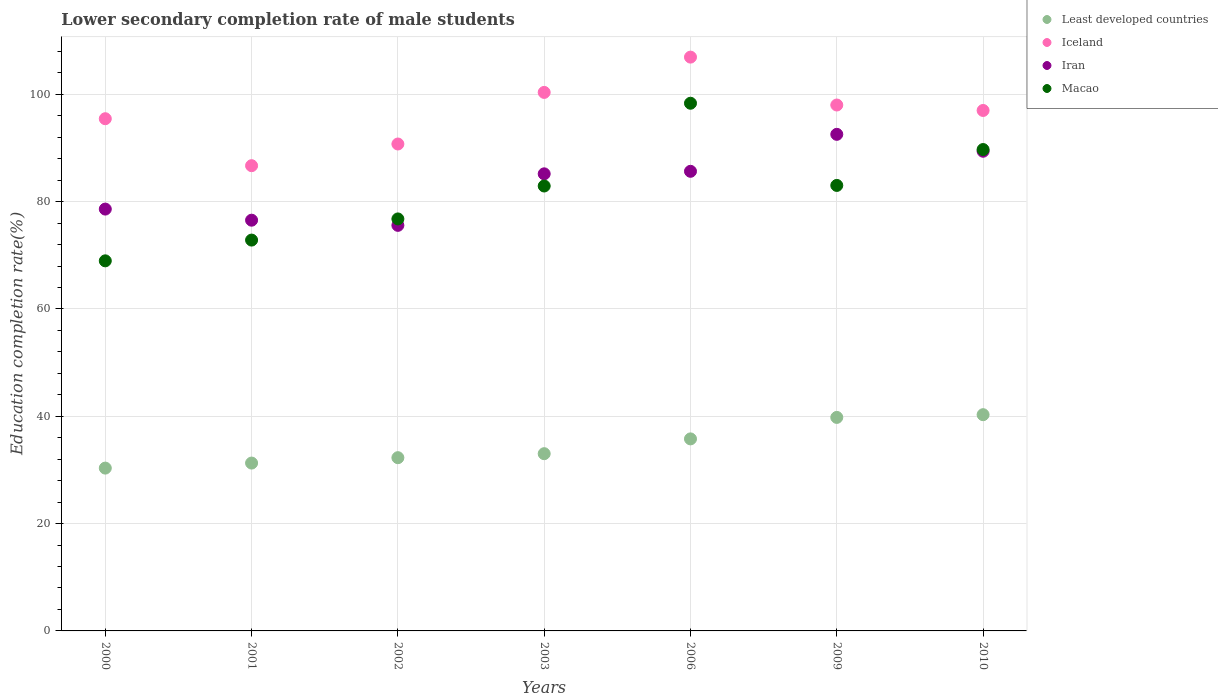How many different coloured dotlines are there?
Provide a succinct answer. 4. What is the lower secondary completion rate of male students in Iran in 2002?
Give a very brief answer. 75.59. Across all years, what is the maximum lower secondary completion rate of male students in Iran?
Keep it short and to the point. 92.55. Across all years, what is the minimum lower secondary completion rate of male students in Iceland?
Offer a terse response. 86.71. In which year was the lower secondary completion rate of male students in Macao maximum?
Your answer should be compact. 2006. In which year was the lower secondary completion rate of male students in Iceland minimum?
Make the answer very short. 2001. What is the total lower secondary completion rate of male students in Iran in the graph?
Your response must be concise. 583.57. What is the difference between the lower secondary completion rate of male students in Macao in 2001 and that in 2009?
Make the answer very short. -10.19. What is the difference between the lower secondary completion rate of male students in Iran in 2006 and the lower secondary completion rate of male students in Least developed countries in 2002?
Provide a short and direct response. 53.37. What is the average lower secondary completion rate of male students in Macao per year?
Your response must be concise. 81.8. In the year 2006, what is the difference between the lower secondary completion rate of male students in Iran and lower secondary completion rate of male students in Least developed countries?
Your answer should be very brief. 49.87. What is the ratio of the lower secondary completion rate of male students in Macao in 2001 to that in 2002?
Your answer should be compact. 0.95. Is the lower secondary completion rate of male students in Least developed countries in 2001 less than that in 2010?
Provide a short and direct response. Yes. Is the difference between the lower secondary completion rate of male students in Iran in 2000 and 2010 greater than the difference between the lower secondary completion rate of male students in Least developed countries in 2000 and 2010?
Offer a terse response. No. What is the difference between the highest and the second highest lower secondary completion rate of male students in Iran?
Make the answer very short. 3.15. What is the difference between the highest and the lowest lower secondary completion rate of male students in Iran?
Give a very brief answer. 16.96. Is the sum of the lower secondary completion rate of male students in Least developed countries in 2001 and 2009 greater than the maximum lower secondary completion rate of male students in Iran across all years?
Your answer should be compact. No. Does the lower secondary completion rate of male students in Least developed countries monotonically increase over the years?
Offer a very short reply. Yes. Is the lower secondary completion rate of male students in Iceland strictly less than the lower secondary completion rate of male students in Iran over the years?
Ensure brevity in your answer.  No. Does the graph contain any zero values?
Ensure brevity in your answer.  No. Does the graph contain grids?
Your answer should be compact. Yes. What is the title of the graph?
Give a very brief answer. Lower secondary completion rate of male students. Does "Fragile and conflict affected situations" appear as one of the legend labels in the graph?
Ensure brevity in your answer.  No. What is the label or title of the Y-axis?
Keep it short and to the point. Education completion rate(%). What is the Education completion rate(%) of Least developed countries in 2000?
Offer a terse response. 30.35. What is the Education completion rate(%) in Iceland in 2000?
Ensure brevity in your answer.  95.46. What is the Education completion rate(%) in Iran in 2000?
Offer a terse response. 78.62. What is the Education completion rate(%) in Macao in 2000?
Your answer should be compact. 68.98. What is the Education completion rate(%) of Least developed countries in 2001?
Provide a succinct answer. 31.28. What is the Education completion rate(%) of Iceland in 2001?
Make the answer very short. 86.71. What is the Education completion rate(%) in Iran in 2001?
Offer a very short reply. 76.55. What is the Education completion rate(%) in Macao in 2001?
Provide a short and direct response. 72.84. What is the Education completion rate(%) of Least developed countries in 2002?
Give a very brief answer. 32.29. What is the Education completion rate(%) in Iceland in 2002?
Give a very brief answer. 90.75. What is the Education completion rate(%) of Iran in 2002?
Provide a succinct answer. 75.59. What is the Education completion rate(%) in Macao in 2002?
Ensure brevity in your answer.  76.79. What is the Education completion rate(%) of Least developed countries in 2003?
Make the answer very short. 33.03. What is the Education completion rate(%) in Iceland in 2003?
Your answer should be very brief. 100.37. What is the Education completion rate(%) of Iran in 2003?
Provide a succinct answer. 85.19. What is the Education completion rate(%) of Macao in 2003?
Your response must be concise. 82.92. What is the Education completion rate(%) in Least developed countries in 2006?
Give a very brief answer. 35.79. What is the Education completion rate(%) in Iceland in 2006?
Your response must be concise. 106.94. What is the Education completion rate(%) of Iran in 2006?
Provide a short and direct response. 85.66. What is the Education completion rate(%) of Macao in 2006?
Give a very brief answer. 98.35. What is the Education completion rate(%) in Least developed countries in 2009?
Ensure brevity in your answer.  39.79. What is the Education completion rate(%) in Iceland in 2009?
Offer a very short reply. 98.02. What is the Education completion rate(%) in Iran in 2009?
Offer a terse response. 92.55. What is the Education completion rate(%) of Macao in 2009?
Provide a short and direct response. 83.03. What is the Education completion rate(%) of Least developed countries in 2010?
Keep it short and to the point. 40.3. What is the Education completion rate(%) in Iceland in 2010?
Your answer should be very brief. 97. What is the Education completion rate(%) of Iran in 2010?
Your answer should be very brief. 89.4. What is the Education completion rate(%) of Macao in 2010?
Your answer should be very brief. 89.72. Across all years, what is the maximum Education completion rate(%) of Least developed countries?
Give a very brief answer. 40.3. Across all years, what is the maximum Education completion rate(%) of Iceland?
Make the answer very short. 106.94. Across all years, what is the maximum Education completion rate(%) of Iran?
Keep it short and to the point. 92.55. Across all years, what is the maximum Education completion rate(%) in Macao?
Your response must be concise. 98.35. Across all years, what is the minimum Education completion rate(%) of Least developed countries?
Provide a short and direct response. 30.35. Across all years, what is the minimum Education completion rate(%) of Iceland?
Provide a succinct answer. 86.71. Across all years, what is the minimum Education completion rate(%) in Iran?
Your answer should be compact. 75.59. Across all years, what is the minimum Education completion rate(%) in Macao?
Make the answer very short. 68.98. What is the total Education completion rate(%) in Least developed countries in the graph?
Give a very brief answer. 242.84. What is the total Education completion rate(%) in Iceland in the graph?
Provide a short and direct response. 675.25. What is the total Education completion rate(%) of Iran in the graph?
Make the answer very short. 583.57. What is the total Education completion rate(%) in Macao in the graph?
Provide a succinct answer. 572.63. What is the difference between the Education completion rate(%) in Least developed countries in 2000 and that in 2001?
Your response must be concise. -0.94. What is the difference between the Education completion rate(%) in Iceland in 2000 and that in 2001?
Keep it short and to the point. 8.75. What is the difference between the Education completion rate(%) in Iran in 2000 and that in 2001?
Your answer should be compact. 2.07. What is the difference between the Education completion rate(%) in Macao in 2000 and that in 2001?
Give a very brief answer. -3.87. What is the difference between the Education completion rate(%) in Least developed countries in 2000 and that in 2002?
Provide a short and direct response. -1.94. What is the difference between the Education completion rate(%) of Iceland in 2000 and that in 2002?
Give a very brief answer. 4.71. What is the difference between the Education completion rate(%) in Iran in 2000 and that in 2002?
Your response must be concise. 3.03. What is the difference between the Education completion rate(%) of Macao in 2000 and that in 2002?
Your response must be concise. -7.81. What is the difference between the Education completion rate(%) of Least developed countries in 2000 and that in 2003?
Provide a succinct answer. -2.69. What is the difference between the Education completion rate(%) of Iceland in 2000 and that in 2003?
Give a very brief answer. -4.9. What is the difference between the Education completion rate(%) of Iran in 2000 and that in 2003?
Your answer should be compact. -6.57. What is the difference between the Education completion rate(%) of Macao in 2000 and that in 2003?
Make the answer very short. -13.95. What is the difference between the Education completion rate(%) of Least developed countries in 2000 and that in 2006?
Offer a terse response. -5.44. What is the difference between the Education completion rate(%) in Iceland in 2000 and that in 2006?
Make the answer very short. -11.48. What is the difference between the Education completion rate(%) of Iran in 2000 and that in 2006?
Ensure brevity in your answer.  -7.04. What is the difference between the Education completion rate(%) of Macao in 2000 and that in 2006?
Offer a very short reply. -29.37. What is the difference between the Education completion rate(%) in Least developed countries in 2000 and that in 2009?
Provide a short and direct response. -9.45. What is the difference between the Education completion rate(%) in Iceland in 2000 and that in 2009?
Give a very brief answer. -2.55. What is the difference between the Education completion rate(%) in Iran in 2000 and that in 2009?
Your answer should be compact. -13.93. What is the difference between the Education completion rate(%) in Macao in 2000 and that in 2009?
Offer a very short reply. -14.05. What is the difference between the Education completion rate(%) of Least developed countries in 2000 and that in 2010?
Ensure brevity in your answer.  -9.96. What is the difference between the Education completion rate(%) in Iceland in 2000 and that in 2010?
Your answer should be compact. -1.54. What is the difference between the Education completion rate(%) of Iran in 2000 and that in 2010?
Provide a short and direct response. -10.78. What is the difference between the Education completion rate(%) of Macao in 2000 and that in 2010?
Your response must be concise. -20.74. What is the difference between the Education completion rate(%) of Least developed countries in 2001 and that in 2002?
Offer a terse response. -1. What is the difference between the Education completion rate(%) of Iceland in 2001 and that in 2002?
Your response must be concise. -4.04. What is the difference between the Education completion rate(%) of Iran in 2001 and that in 2002?
Your answer should be compact. 0.96. What is the difference between the Education completion rate(%) in Macao in 2001 and that in 2002?
Provide a succinct answer. -3.94. What is the difference between the Education completion rate(%) of Least developed countries in 2001 and that in 2003?
Provide a succinct answer. -1.75. What is the difference between the Education completion rate(%) in Iceland in 2001 and that in 2003?
Provide a short and direct response. -13.66. What is the difference between the Education completion rate(%) in Iran in 2001 and that in 2003?
Offer a terse response. -8.64. What is the difference between the Education completion rate(%) in Macao in 2001 and that in 2003?
Offer a terse response. -10.08. What is the difference between the Education completion rate(%) in Least developed countries in 2001 and that in 2006?
Your response must be concise. -4.51. What is the difference between the Education completion rate(%) in Iceland in 2001 and that in 2006?
Provide a succinct answer. -20.23. What is the difference between the Education completion rate(%) of Iran in 2001 and that in 2006?
Your answer should be compact. -9.11. What is the difference between the Education completion rate(%) in Macao in 2001 and that in 2006?
Make the answer very short. -25.5. What is the difference between the Education completion rate(%) in Least developed countries in 2001 and that in 2009?
Offer a terse response. -8.51. What is the difference between the Education completion rate(%) of Iceland in 2001 and that in 2009?
Keep it short and to the point. -11.31. What is the difference between the Education completion rate(%) in Iran in 2001 and that in 2009?
Make the answer very short. -16. What is the difference between the Education completion rate(%) in Macao in 2001 and that in 2009?
Ensure brevity in your answer.  -10.19. What is the difference between the Education completion rate(%) in Least developed countries in 2001 and that in 2010?
Your response must be concise. -9.02. What is the difference between the Education completion rate(%) of Iceland in 2001 and that in 2010?
Your answer should be compact. -10.29. What is the difference between the Education completion rate(%) of Iran in 2001 and that in 2010?
Your answer should be very brief. -12.85. What is the difference between the Education completion rate(%) of Macao in 2001 and that in 2010?
Give a very brief answer. -16.88. What is the difference between the Education completion rate(%) of Least developed countries in 2002 and that in 2003?
Ensure brevity in your answer.  -0.74. What is the difference between the Education completion rate(%) in Iceland in 2002 and that in 2003?
Provide a succinct answer. -9.62. What is the difference between the Education completion rate(%) in Iran in 2002 and that in 2003?
Your answer should be very brief. -9.6. What is the difference between the Education completion rate(%) of Macao in 2002 and that in 2003?
Ensure brevity in your answer.  -6.14. What is the difference between the Education completion rate(%) in Least developed countries in 2002 and that in 2006?
Provide a short and direct response. -3.5. What is the difference between the Education completion rate(%) of Iceland in 2002 and that in 2006?
Ensure brevity in your answer.  -16.19. What is the difference between the Education completion rate(%) of Iran in 2002 and that in 2006?
Provide a succinct answer. -10.07. What is the difference between the Education completion rate(%) of Macao in 2002 and that in 2006?
Your answer should be very brief. -21.56. What is the difference between the Education completion rate(%) in Least developed countries in 2002 and that in 2009?
Ensure brevity in your answer.  -7.51. What is the difference between the Education completion rate(%) in Iceland in 2002 and that in 2009?
Your response must be concise. -7.27. What is the difference between the Education completion rate(%) in Iran in 2002 and that in 2009?
Provide a short and direct response. -16.96. What is the difference between the Education completion rate(%) of Macao in 2002 and that in 2009?
Offer a terse response. -6.24. What is the difference between the Education completion rate(%) in Least developed countries in 2002 and that in 2010?
Provide a short and direct response. -8.01. What is the difference between the Education completion rate(%) in Iceland in 2002 and that in 2010?
Offer a very short reply. -6.25. What is the difference between the Education completion rate(%) in Iran in 2002 and that in 2010?
Offer a terse response. -13.81. What is the difference between the Education completion rate(%) in Macao in 2002 and that in 2010?
Your answer should be very brief. -12.93. What is the difference between the Education completion rate(%) of Least developed countries in 2003 and that in 2006?
Provide a short and direct response. -2.76. What is the difference between the Education completion rate(%) of Iceland in 2003 and that in 2006?
Keep it short and to the point. -6.58. What is the difference between the Education completion rate(%) in Iran in 2003 and that in 2006?
Your answer should be compact. -0.47. What is the difference between the Education completion rate(%) of Macao in 2003 and that in 2006?
Give a very brief answer. -15.42. What is the difference between the Education completion rate(%) in Least developed countries in 2003 and that in 2009?
Give a very brief answer. -6.76. What is the difference between the Education completion rate(%) in Iceland in 2003 and that in 2009?
Offer a very short reply. 2.35. What is the difference between the Education completion rate(%) in Iran in 2003 and that in 2009?
Your answer should be very brief. -7.36. What is the difference between the Education completion rate(%) of Macao in 2003 and that in 2009?
Provide a short and direct response. -0.11. What is the difference between the Education completion rate(%) of Least developed countries in 2003 and that in 2010?
Provide a short and direct response. -7.27. What is the difference between the Education completion rate(%) in Iceland in 2003 and that in 2010?
Provide a succinct answer. 3.37. What is the difference between the Education completion rate(%) in Iran in 2003 and that in 2010?
Provide a short and direct response. -4.21. What is the difference between the Education completion rate(%) in Macao in 2003 and that in 2010?
Your response must be concise. -6.8. What is the difference between the Education completion rate(%) of Least developed countries in 2006 and that in 2009?
Make the answer very short. -4. What is the difference between the Education completion rate(%) of Iceland in 2006 and that in 2009?
Give a very brief answer. 8.93. What is the difference between the Education completion rate(%) of Iran in 2006 and that in 2009?
Your response must be concise. -6.89. What is the difference between the Education completion rate(%) in Macao in 2006 and that in 2009?
Your response must be concise. 15.32. What is the difference between the Education completion rate(%) of Least developed countries in 2006 and that in 2010?
Your response must be concise. -4.51. What is the difference between the Education completion rate(%) in Iceland in 2006 and that in 2010?
Offer a terse response. 9.94. What is the difference between the Education completion rate(%) of Iran in 2006 and that in 2010?
Provide a short and direct response. -3.74. What is the difference between the Education completion rate(%) in Macao in 2006 and that in 2010?
Make the answer very short. 8.63. What is the difference between the Education completion rate(%) of Least developed countries in 2009 and that in 2010?
Provide a succinct answer. -0.51. What is the difference between the Education completion rate(%) of Iceland in 2009 and that in 2010?
Provide a short and direct response. 1.02. What is the difference between the Education completion rate(%) in Iran in 2009 and that in 2010?
Offer a very short reply. 3.15. What is the difference between the Education completion rate(%) of Macao in 2009 and that in 2010?
Offer a terse response. -6.69. What is the difference between the Education completion rate(%) of Least developed countries in 2000 and the Education completion rate(%) of Iceland in 2001?
Provide a succinct answer. -56.36. What is the difference between the Education completion rate(%) in Least developed countries in 2000 and the Education completion rate(%) in Iran in 2001?
Keep it short and to the point. -46.21. What is the difference between the Education completion rate(%) in Least developed countries in 2000 and the Education completion rate(%) in Macao in 2001?
Provide a short and direct response. -42.5. What is the difference between the Education completion rate(%) of Iceland in 2000 and the Education completion rate(%) of Iran in 2001?
Make the answer very short. 18.91. What is the difference between the Education completion rate(%) in Iceland in 2000 and the Education completion rate(%) in Macao in 2001?
Offer a very short reply. 22.62. What is the difference between the Education completion rate(%) in Iran in 2000 and the Education completion rate(%) in Macao in 2001?
Provide a succinct answer. 5.78. What is the difference between the Education completion rate(%) of Least developed countries in 2000 and the Education completion rate(%) of Iceland in 2002?
Your answer should be very brief. -60.41. What is the difference between the Education completion rate(%) of Least developed countries in 2000 and the Education completion rate(%) of Iran in 2002?
Provide a succinct answer. -45.24. What is the difference between the Education completion rate(%) in Least developed countries in 2000 and the Education completion rate(%) in Macao in 2002?
Your answer should be very brief. -46.44. What is the difference between the Education completion rate(%) of Iceland in 2000 and the Education completion rate(%) of Iran in 2002?
Your answer should be compact. 19.87. What is the difference between the Education completion rate(%) in Iceland in 2000 and the Education completion rate(%) in Macao in 2002?
Keep it short and to the point. 18.68. What is the difference between the Education completion rate(%) in Iran in 2000 and the Education completion rate(%) in Macao in 2002?
Give a very brief answer. 1.84. What is the difference between the Education completion rate(%) in Least developed countries in 2000 and the Education completion rate(%) in Iceland in 2003?
Provide a succinct answer. -70.02. What is the difference between the Education completion rate(%) of Least developed countries in 2000 and the Education completion rate(%) of Iran in 2003?
Keep it short and to the point. -54.85. What is the difference between the Education completion rate(%) in Least developed countries in 2000 and the Education completion rate(%) in Macao in 2003?
Provide a succinct answer. -52.58. What is the difference between the Education completion rate(%) in Iceland in 2000 and the Education completion rate(%) in Iran in 2003?
Your answer should be very brief. 10.27. What is the difference between the Education completion rate(%) in Iceland in 2000 and the Education completion rate(%) in Macao in 2003?
Provide a short and direct response. 12.54. What is the difference between the Education completion rate(%) in Iran in 2000 and the Education completion rate(%) in Macao in 2003?
Your response must be concise. -4.3. What is the difference between the Education completion rate(%) of Least developed countries in 2000 and the Education completion rate(%) of Iceland in 2006?
Offer a terse response. -76.6. What is the difference between the Education completion rate(%) of Least developed countries in 2000 and the Education completion rate(%) of Iran in 2006?
Your answer should be very brief. -55.32. What is the difference between the Education completion rate(%) in Least developed countries in 2000 and the Education completion rate(%) in Macao in 2006?
Offer a terse response. -68. What is the difference between the Education completion rate(%) of Iceland in 2000 and the Education completion rate(%) of Iran in 2006?
Provide a succinct answer. 9.8. What is the difference between the Education completion rate(%) of Iceland in 2000 and the Education completion rate(%) of Macao in 2006?
Your response must be concise. -2.88. What is the difference between the Education completion rate(%) in Iran in 2000 and the Education completion rate(%) in Macao in 2006?
Offer a terse response. -19.73. What is the difference between the Education completion rate(%) in Least developed countries in 2000 and the Education completion rate(%) in Iceland in 2009?
Keep it short and to the point. -67.67. What is the difference between the Education completion rate(%) of Least developed countries in 2000 and the Education completion rate(%) of Iran in 2009?
Keep it short and to the point. -62.21. What is the difference between the Education completion rate(%) of Least developed countries in 2000 and the Education completion rate(%) of Macao in 2009?
Provide a succinct answer. -52.68. What is the difference between the Education completion rate(%) of Iceland in 2000 and the Education completion rate(%) of Iran in 2009?
Your answer should be very brief. 2.91. What is the difference between the Education completion rate(%) in Iceland in 2000 and the Education completion rate(%) in Macao in 2009?
Offer a terse response. 12.43. What is the difference between the Education completion rate(%) in Iran in 2000 and the Education completion rate(%) in Macao in 2009?
Provide a short and direct response. -4.41. What is the difference between the Education completion rate(%) in Least developed countries in 2000 and the Education completion rate(%) in Iceland in 2010?
Offer a very short reply. -66.66. What is the difference between the Education completion rate(%) of Least developed countries in 2000 and the Education completion rate(%) of Iran in 2010?
Your answer should be compact. -59.05. What is the difference between the Education completion rate(%) in Least developed countries in 2000 and the Education completion rate(%) in Macao in 2010?
Give a very brief answer. -59.37. What is the difference between the Education completion rate(%) of Iceland in 2000 and the Education completion rate(%) of Iran in 2010?
Offer a very short reply. 6.06. What is the difference between the Education completion rate(%) in Iceland in 2000 and the Education completion rate(%) in Macao in 2010?
Your response must be concise. 5.74. What is the difference between the Education completion rate(%) of Iran in 2000 and the Education completion rate(%) of Macao in 2010?
Ensure brevity in your answer.  -11.1. What is the difference between the Education completion rate(%) in Least developed countries in 2001 and the Education completion rate(%) in Iceland in 2002?
Make the answer very short. -59.47. What is the difference between the Education completion rate(%) in Least developed countries in 2001 and the Education completion rate(%) in Iran in 2002?
Offer a terse response. -44.3. What is the difference between the Education completion rate(%) in Least developed countries in 2001 and the Education completion rate(%) in Macao in 2002?
Your response must be concise. -45.5. What is the difference between the Education completion rate(%) in Iceland in 2001 and the Education completion rate(%) in Iran in 2002?
Provide a succinct answer. 11.12. What is the difference between the Education completion rate(%) of Iceland in 2001 and the Education completion rate(%) of Macao in 2002?
Make the answer very short. 9.92. What is the difference between the Education completion rate(%) in Iran in 2001 and the Education completion rate(%) in Macao in 2002?
Make the answer very short. -0.23. What is the difference between the Education completion rate(%) of Least developed countries in 2001 and the Education completion rate(%) of Iceland in 2003?
Provide a short and direct response. -69.08. What is the difference between the Education completion rate(%) in Least developed countries in 2001 and the Education completion rate(%) in Iran in 2003?
Your response must be concise. -53.91. What is the difference between the Education completion rate(%) of Least developed countries in 2001 and the Education completion rate(%) of Macao in 2003?
Make the answer very short. -51.64. What is the difference between the Education completion rate(%) in Iceland in 2001 and the Education completion rate(%) in Iran in 2003?
Your response must be concise. 1.52. What is the difference between the Education completion rate(%) in Iceland in 2001 and the Education completion rate(%) in Macao in 2003?
Give a very brief answer. 3.79. What is the difference between the Education completion rate(%) of Iran in 2001 and the Education completion rate(%) of Macao in 2003?
Make the answer very short. -6.37. What is the difference between the Education completion rate(%) of Least developed countries in 2001 and the Education completion rate(%) of Iceland in 2006?
Give a very brief answer. -75.66. What is the difference between the Education completion rate(%) of Least developed countries in 2001 and the Education completion rate(%) of Iran in 2006?
Provide a short and direct response. -54.38. What is the difference between the Education completion rate(%) in Least developed countries in 2001 and the Education completion rate(%) in Macao in 2006?
Make the answer very short. -67.06. What is the difference between the Education completion rate(%) of Iceland in 2001 and the Education completion rate(%) of Iran in 2006?
Give a very brief answer. 1.05. What is the difference between the Education completion rate(%) in Iceland in 2001 and the Education completion rate(%) in Macao in 2006?
Your answer should be very brief. -11.64. What is the difference between the Education completion rate(%) of Iran in 2001 and the Education completion rate(%) of Macao in 2006?
Ensure brevity in your answer.  -21.8. What is the difference between the Education completion rate(%) in Least developed countries in 2001 and the Education completion rate(%) in Iceland in 2009?
Your response must be concise. -66.73. What is the difference between the Education completion rate(%) in Least developed countries in 2001 and the Education completion rate(%) in Iran in 2009?
Your answer should be compact. -61.27. What is the difference between the Education completion rate(%) of Least developed countries in 2001 and the Education completion rate(%) of Macao in 2009?
Give a very brief answer. -51.75. What is the difference between the Education completion rate(%) in Iceland in 2001 and the Education completion rate(%) in Iran in 2009?
Your answer should be compact. -5.84. What is the difference between the Education completion rate(%) in Iceland in 2001 and the Education completion rate(%) in Macao in 2009?
Make the answer very short. 3.68. What is the difference between the Education completion rate(%) of Iran in 2001 and the Education completion rate(%) of Macao in 2009?
Give a very brief answer. -6.48. What is the difference between the Education completion rate(%) in Least developed countries in 2001 and the Education completion rate(%) in Iceland in 2010?
Your answer should be very brief. -65.72. What is the difference between the Education completion rate(%) in Least developed countries in 2001 and the Education completion rate(%) in Iran in 2010?
Your answer should be compact. -58.12. What is the difference between the Education completion rate(%) of Least developed countries in 2001 and the Education completion rate(%) of Macao in 2010?
Ensure brevity in your answer.  -58.44. What is the difference between the Education completion rate(%) of Iceland in 2001 and the Education completion rate(%) of Iran in 2010?
Offer a terse response. -2.69. What is the difference between the Education completion rate(%) of Iceland in 2001 and the Education completion rate(%) of Macao in 2010?
Give a very brief answer. -3.01. What is the difference between the Education completion rate(%) in Iran in 2001 and the Education completion rate(%) in Macao in 2010?
Provide a succinct answer. -13.17. What is the difference between the Education completion rate(%) of Least developed countries in 2002 and the Education completion rate(%) of Iceland in 2003?
Keep it short and to the point. -68.08. What is the difference between the Education completion rate(%) of Least developed countries in 2002 and the Education completion rate(%) of Iran in 2003?
Offer a terse response. -52.9. What is the difference between the Education completion rate(%) in Least developed countries in 2002 and the Education completion rate(%) in Macao in 2003?
Provide a succinct answer. -50.63. What is the difference between the Education completion rate(%) in Iceland in 2002 and the Education completion rate(%) in Iran in 2003?
Your answer should be compact. 5.56. What is the difference between the Education completion rate(%) of Iceland in 2002 and the Education completion rate(%) of Macao in 2003?
Offer a terse response. 7.83. What is the difference between the Education completion rate(%) of Iran in 2002 and the Education completion rate(%) of Macao in 2003?
Your answer should be compact. -7.33. What is the difference between the Education completion rate(%) in Least developed countries in 2002 and the Education completion rate(%) in Iceland in 2006?
Provide a succinct answer. -74.66. What is the difference between the Education completion rate(%) in Least developed countries in 2002 and the Education completion rate(%) in Iran in 2006?
Offer a terse response. -53.37. What is the difference between the Education completion rate(%) in Least developed countries in 2002 and the Education completion rate(%) in Macao in 2006?
Your response must be concise. -66.06. What is the difference between the Education completion rate(%) in Iceland in 2002 and the Education completion rate(%) in Iran in 2006?
Your answer should be compact. 5.09. What is the difference between the Education completion rate(%) in Iceland in 2002 and the Education completion rate(%) in Macao in 2006?
Give a very brief answer. -7.6. What is the difference between the Education completion rate(%) of Iran in 2002 and the Education completion rate(%) of Macao in 2006?
Give a very brief answer. -22.76. What is the difference between the Education completion rate(%) of Least developed countries in 2002 and the Education completion rate(%) of Iceland in 2009?
Give a very brief answer. -65.73. What is the difference between the Education completion rate(%) of Least developed countries in 2002 and the Education completion rate(%) of Iran in 2009?
Make the answer very short. -60.26. What is the difference between the Education completion rate(%) in Least developed countries in 2002 and the Education completion rate(%) in Macao in 2009?
Provide a succinct answer. -50.74. What is the difference between the Education completion rate(%) in Iceland in 2002 and the Education completion rate(%) in Iran in 2009?
Make the answer very short. -1.8. What is the difference between the Education completion rate(%) of Iceland in 2002 and the Education completion rate(%) of Macao in 2009?
Offer a very short reply. 7.72. What is the difference between the Education completion rate(%) of Iran in 2002 and the Education completion rate(%) of Macao in 2009?
Your response must be concise. -7.44. What is the difference between the Education completion rate(%) in Least developed countries in 2002 and the Education completion rate(%) in Iceland in 2010?
Provide a succinct answer. -64.71. What is the difference between the Education completion rate(%) in Least developed countries in 2002 and the Education completion rate(%) in Iran in 2010?
Offer a terse response. -57.11. What is the difference between the Education completion rate(%) in Least developed countries in 2002 and the Education completion rate(%) in Macao in 2010?
Offer a very short reply. -57.43. What is the difference between the Education completion rate(%) in Iceland in 2002 and the Education completion rate(%) in Iran in 2010?
Your response must be concise. 1.35. What is the difference between the Education completion rate(%) of Iceland in 2002 and the Education completion rate(%) of Macao in 2010?
Your answer should be compact. 1.03. What is the difference between the Education completion rate(%) of Iran in 2002 and the Education completion rate(%) of Macao in 2010?
Offer a terse response. -14.13. What is the difference between the Education completion rate(%) of Least developed countries in 2003 and the Education completion rate(%) of Iceland in 2006?
Your answer should be very brief. -73.91. What is the difference between the Education completion rate(%) of Least developed countries in 2003 and the Education completion rate(%) of Iran in 2006?
Your response must be concise. -52.63. What is the difference between the Education completion rate(%) in Least developed countries in 2003 and the Education completion rate(%) in Macao in 2006?
Your response must be concise. -65.31. What is the difference between the Education completion rate(%) in Iceland in 2003 and the Education completion rate(%) in Iran in 2006?
Your answer should be very brief. 14.7. What is the difference between the Education completion rate(%) in Iceland in 2003 and the Education completion rate(%) in Macao in 2006?
Your answer should be compact. 2.02. What is the difference between the Education completion rate(%) of Iran in 2003 and the Education completion rate(%) of Macao in 2006?
Offer a very short reply. -13.15. What is the difference between the Education completion rate(%) of Least developed countries in 2003 and the Education completion rate(%) of Iceland in 2009?
Offer a terse response. -64.98. What is the difference between the Education completion rate(%) in Least developed countries in 2003 and the Education completion rate(%) in Iran in 2009?
Your answer should be very brief. -59.52. What is the difference between the Education completion rate(%) in Least developed countries in 2003 and the Education completion rate(%) in Macao in 2009?
Make the answer very short. -50. What is the difference between the Education completion rate(%) in Iceland in 2003 and the Education completion rate(%) in Iran in 2009?
Keep it short and to the point. 7.81. What is the difference between the Education completion rate(%) in Iceland in 2003 and the Education completion rate(%) in Macao in 2009?
Provide a succinct answer. 17.34. What is the difference between the Education completion rate(%) of Iran in 2003 and the Education completion rate(%) of Macao in 2009?
Provide a short and direct response. 2.16. What is the difference between the Education completion rate(%) in Least developed countries in 2003 and the Education completion rate(%) in Iceland in 2010?
Provide a short and direct response. -63.97. What is the difference between the Education completion rate(%) in Least developed countries in 2003 and the Education completion rate(%) in Iran in 2010?
Keep it short and to the point. -56.37. What is the difference between the Education completion rate(%) in Least developed countries in 2003 and the Education completion rate(%) in Macao in 2010?
Your answer should be very brief. -56.69. What is the difference between the Education completion rate(%) of Iceland in 2003 and the Education completion rate(%) of Iran in 2010?
Give a very brief answer. 10.97. What is the difference between the Education completion rate(%) of Iceland in 2003 and the Education completion rate(%) of Macao in 2010?
Your answer should be very brief. 10.65. What is the difference between the Education completion rate(%) in Iran in 2003 and the Education completion rate(%) in Macao in 2010?
Provide a succinct answer. -4.53. What is the difference between the Education completion rate(%) of Least developed countries in 2006 and the Education completion rate(%) of Iceland in 2009?
Provide a succinct answer. -62.23. What is the difference between the Education completion rate(%) in Least developed countries in 2006 and the Education completion rate(%) in Iran in 2009?
Provide a succinct answer. -56.76. What is the difference between the Education completion rate(%) in Least developed countries in 2006 and the Education completion rate(%) in Macao in 2009?
Your answer should be very brief. -47.24. What is the difference between the Education completion rate(%) in Iceland in 2006 and the Education completion rate(%) in Iran in 2009?
Offer a very short reply. 14.39. What is the difference between the Education completion rate(%) of Iceland in 2006 and the Education completion rate(%) of Macao in 2009?
Offer a very short reply. 23.91. What is the difference between the Education completion rate(%) of Iran in 2006 and the Education completion rate(%) of Macao in 2009?
Ensure brevity in your answer.  2.63. What is the difference between the Education completion rate(%) of Least developed countries in 2006 and the Education completion rate(%) of Iceland in 2010?
Keep it short and to the point. -61.21. What is the difference between the Education completion rate(%) in Least developed countries in 2006 and the Education completion rate(%) in Iran in 2010?
Offer a terse response. -53.61. What is the difference between the Education completion rate(%) in Least developed countries in 2006 and the Education completion rate(%) in Macao in 2010?
Make the answer very short. -53.93. What is the difference between the Education completion rate(%) in Iceland in 2006 and the Education completion rate(%) in Iran in 2010?
Your answer should be very brief. 17.54. What is the difference between the Education completion rate(%) in Iceland in 2006 and the Education completion rate(%) in Macao in 2010?
Provide a succinct answer. 17.22. What is the difference between the Education completion rate(%) of Iran in 2006 and the Education completion rate(%) of Macao in 2010?
Provide a succinct answer. -4.06. What is the difference between the Education completion rate(%) of Least developed countries in 2009 and the Education completion rate(%) of Iceland in 2010?
Make the answer very short. -57.21. What is the difference between the Education completion rate(%) in Least developed countries in 2009 and the Education completion rate(%) in Iran in 2010?
Your response must be concise. -49.61. What is the difference between the Education completion rate(%) in Least developed countries in 2009 and the Education completion rate(%) in Macao in 2010?
Offer a very short reply. -49.93. What is the difference between the Education completion rate(%) of Iceland in 2009 and the Education completion rate(%) of Iran in 2010?
Keep it short and to the point. 8.62. What is the difference between the Education completion rate(%) of Iceland in 2009 and the Education completion rate(%) of Macao in 2010?
Make the answer very short. 8.3. What is the difference between the Education completion rate(%) of Iran in 2009 and the Education completion rate(%) of Macao in 2010?
Your response must be concise. 2.83. What is the average Education completion rate(%) in Least developed countries per year?
Provide a succinct answer. 34.69. What is the average Education completion rate(%) in Iceland per year?
Provide a succinct answer. 96.46. What is the average Education completion rate(%) in Iran per year?
Provide a short and direct response. 83.37. What is the average Education completion rate(%) of Macao per year?
Provide a short and direct response. 81.8. In the year 2000, what is the difference between the Education completion rate(%) in Least developed countries and Education completion rate(%) in Iceland?
Offer a very short reply. -65.12. In the year 2000, what is the difference between the Education completion rate(%) in Least developed countries and Education completion rate(%) in Iran?
Make the answer very short. -48.28. In the year 2000, what is the difference between the Education completion rate(%) of Least developed countries and Education completion rate(%) of Macao?
Give a very brief answer. -38.63. In the year 2000, what is the difference between the Education completion rate(%) in Iceland and Education completion rate(%) in Iran?
Provide a succinct answer. 16.84. In the year 2000, what is the difference between the Education completion rate(%) in Iceland and Education completion rate(%) in Macao?
Offer a terse response. 26.49. In the year 2000, what is the difference between the Education completion rate(%) in Iran and Education completion rate(%) in Macao?
Your answer should be compact. 9.65. In the year 2001, what is the difference between the Education completion rate(%) in Least developed countries and Education completion rate(%) in Iceland?
Your answer should be very brief. -55.42. In the year 2001, what is the difference between the Education completion rate(%) of Least developed countries and Education completion rate(%) of Iran?
Keep it short and to the point. -45.27. In the year 2001, what is the difference between the Education completion rate(%) of Least developed countries and Education completion rate(%) of Macao?
Offer a terse response. -41.56. In the year 2001, what is the difference between the Education completion rate(%) in Iceland and Education completion rate(%) in Iran?
Your response must be concise. 10.16. In the year 2001, what is the difference between the Education completion rate(%) of Iceland and Education completion rate(%) of Macao?
Provide a succinct answer. 13.87. In the year 2001, what is the difference between the Education completion rate(%) in Iran and Education completion rate(%) in Macao?
Your answer should be compact. 3.71. In the year 2002, what is the difference between the Education completion rate(%) of Least developed countries and Education completion rate(%) of Iceland?
Provide a short and direct response. -58.46. In the year 2002, what is the difference between the Education completion rate(%) in Least developed countries and Education completion rate(%) in Iran?
Make the answer very short. -43.3. In the year 2002, what is the difference between the Education completion rate(%) of Least developed countries and Education completion rate(%) of Macao?
Offer a very short reply. -44.5. In the year 2002, what is the difference between the Education completion rate(%) in Iceland and Education completion rate(%) in Iran?
Give a very brief answer. 15.16. In the year 2002, what is the difference between the Education completion rate(%) of Iceland and Education completion rate(%) of Macao?
Give a very brief answer. 13.96. In the year 2002, what is the difference between the Education completion rate(%) in Iran and Education completion rate(%) in Macao?
Your response must be concise. -1.2. In the year 2003, what is the difference between the Education completion rate(%) in Least developed countries and Education completion rate(%) in Iceland?
Provide a short and direct response. -67.33. In the year 2003, what is the difference between the Education completion rate(%) in Least developed countries and Education completion rate(%) in Iran?
Make the answer very short. -52.16. In the year 2003, what is the difference between the Education completion rate(%) in Least developed countries and Education completion rate(%) in Macao?
Give a very brief answer. -49.89. In the year 2003, what is the difference between the Education completion rate(%) of Iceland and Education completion rate(%) of Iran?
Give a very brief answer. 15.17. In the year 2003, what is the difference between the Education completion rate(%) of Iceland and Education completion rate(%) of Macao?
Your answer should be very brief. 17.44. In the year 2003, what is the difference between the Education completion rate(%) in Iran and Education completion rate(%) in Macao?
Keep it short and to the point. 2.27. In the year 2006, what is the difference between the Education completion rate(%) in Least developed countries and Education completion rate(%) in Iceland?
Your answer should be very brief. -71.15. In the year 2006, what is the difference between the Education completion rate(%) in Least developed countries and Education completion rate(%) in Iran?
Make the answer very short. -49.87. In the year 2006, what is the difference between the Education completion rate(%) of Least developed countries and Education completion rate(%) of Macao?
Offer a terse response. -62.56. In the year 2006, what is the difference between the Education completion rate(%) of Iceland and Education completion rate(%) of Iran?
Provide a short and direct response. 21.28. In the year 2006, what is the difference between the Education completion rate(%) of Iceland and Education completion rate(%) of Macao?
Provide a succinct answer. 8.6. In the year 2006, what is the difference between the Education completion rate(%) of Iran and Education completion rate(%) of Macao?
Make the answer very short. -12.69. In the year 2009, what is the difference between the Education completion rate(%) of Least developed countries and Education completion rate(%) of Iceland?
Offer a very short reply. -58.22. In the year 2009, what is the difference between the Education completion rate(%) of Least developed countries and Education completion rate(%) of Iran?
Provide a short and direct response. -52.76. In the year 2009, what is the difference between the Education completion rate(%) of Least developed countries and Education completion rate(%) of Macao?
Your answer should be very brief. -43.24. In the year 2009, what is the difference between the Education completion rate(%) in Iceland and Education completion rate(%) in Iran?
Your answer should be very brief. 5.47. In the year 2009, what is the difference between the Education completion rate(%) of Iceland and Education completion rate(%) of Macao?
Keep it short and to the point. 14.99. In the year 2009, what is the difference between the Education completion rate(%) of Iran and Education completion rate(%) of Macao?
Ensure brevity in your answer.  9.52. In the year 2010, what is the difference between the Education completion rate(%) in Least developed countries and Education completion rate(%) in Iceland?
Offer a terse response. -56.7. In the year 2010, what is the difference between the Education completion rate(%) of Least developed countries and Education completion rate(%) of Iran?
Offer a terse response. -49.1. In the year 2010, what is the difference between the Education completion rate(%) in Least developed countries and Education completion rate(%) in Macao?
Provide a succinct answer. -49.42. In the year 2010, what is the difference between the Education completion rate(%) in Iceland and Education completion rate(%) in Iran?
Your response must be concise. 7.6. In the year 2010, what is the difference between the Education completion rate(%) of Iceland and Education completion rate(%) of Macao?
Your answer should be very brief. 7.28. In the year 2010, what is the difference between the Education completion rate(%) of Iran and Education completion rate(%) of Macao?
Offer a terse response. -0.32. What is the ratio of the Education completion rate(%) of Least developed countries in 2000 to that in 2001?
Offer a very short reply. 0.97. What is the ratio of the Education completion rate(%) of Iceland in 2000 to that in 2001?
Your answer should be very brief. 1.1. What is the ratio of the Education completion rate(%) of Macao in 2000 to that in 2001?
Provide a succinct answer. 0.95. What is the ratio of the Education completion rate(%) of Least developed countries in 2000 to that in 2002?
Give a very brief answer. 0.94. What is the ratio of the Education completion rate(%) in Iceland in 2000 to that in 2002?
Your answer should be compact. 1.05. What is the ratio of the Education completion rate(%) of Iran in 2000 to that in 2002?
Your answer should be very brief. 1.04. What is the ratio of the Education completion rate(%) of Macao in 2000 to that in 2002?
Your answer should be very brief. 0.9. What is the ratio of the Education completion rate(%) of Least developed countries in 2000 to that in 2003?
Offer a very short reply. 0.92. What is the ratio of the Education completion rate(%) of Iceland in 2000 to that in 2003?
Provide a succinct answer. 0.95. What is the ratio of the Education completion rate(%) in Iran in 2000 to that in 2003?
Offer a terse response. 0.92. What is the ratio of the Education completion rate(%) in Macao in 2000 to that in 2003?
Ensure brevity in your answer.  0.83. What is the ratio of the Education completion rate(%) in Least developed countries in 2000 to that in 2006?
Give a very brief answer. 0.85. What is the ratio of the Education completion rate(%) of Iceland in 2000 to that in 2006?
Give a very brief answer. 0.89. What is the ratio of the Education completion rate(%) of Iran in 2000 to that in 2006?
Keep it short and to the point. 0.92. What is the ratio of the Education completion rate(%) of Macao in 2000 to that in 2006?
Provide a short and direct response. 0.7. What is the ratio of the Education completion rate(%) of Least developed countries in 2000 to that in 2009?
Provide a short and direct response. 0.76. What is the ratio of the Education completion rate(%) of Iceland in 2000 to that in 2009?
Your answer should be compact. 0.97. What is the ratio of the Education completion rate(%) in Iran in 2000 to that in 2009?
Provide a succinct answer. 0.85. What is the ratio of the Education completion rate(%) of Macao in 2000 to that in 2009?
Give a very brief answer. 0.83. What is the ratio of the Education completion rate(%) in Least developed countries in 2000 to that in 2010?
Your answer should be very brief. 0.75. What is the ratio of the Education completion rate(%) in Iceland in 2000 to that in 2010?
Ensure brevity in your answer.  0.98. What is the ratio of the Education completion rate(%) in Iran in 2000 to that in 2010?
Offer a very short reply. 0.88. What is the ratio of the Education completion rate(%) of Macao in 2000 to that in 2010?
Offer a very short reply. 0.77. What is the ratio of the Education completion rate(%) of Least developed countries in 2001 to that in 2002?
Give a very brief answer. 0.97. What is the ratio of the Education completion rate(%) in Iceland in 2001 to that in 2002?
Your answer should be very brief. 0.96. What is the ratio of the Education completion rate(%) of Iran in 2001 to that in 2002?
Provide a short and direct response. 1.01. What is the ratio of the Education completion rate(%) in Macao in 2001 to that in 2002?
Give a very brief answer. 0.95. What is the ratio of the Education completion rate(%) in Least developed countries in 2001 to that in 2003?
Provide a short and direct response. 0.95. What is the ratio of the Education completion rate(%) of Iceland in 2001 to that in 2003?
Ensure brevity in your answer.  0.86. What is the ratio of the Education completion rate(%) in Iran in 2001 to that in 2003?
Keep it short and to the point. 0.9. What is the ratio of the Education completion rate(%) of Macao in 2001 to that in 2003?
Your answer should be compact. 0.88. What is the ratio of the Education completion rate(%) of Least developed countries in 2001 to that in 2006?
Give a very brief answer. 0.87. What is the ratio of the Education completion rate(%) in Iceland in 2001 to that in 2006?
Provide a short and direct response. 0.81. What is the ratio of the Education completion rate(%) of Iran in 2001 to that in 2006?
Offer a terse response. 0.89. What is the ratio of the Education completion rate(%) of Macao in 2001 to that in 2006?
Offer a terse response. 0.74. What is the ratio of the Education completion rate(%) of Least developed countries in 2001 to that in 2009?
Ensure brevity in your answer.  0.79. What is the ratio of the Education completion rate(%) in Iceland in 2001 to that in 2009?
Your answer should be very brief. 0.88. What is the ratio of the Education completion rate(%) in Iran in 2001 to that in 2009?
Your answer should be compact. 0.83. What is the ratio of the Education completion rate(%) in Macao in 2001 to that in 2009?
Keep it short and to the point. 0.88. What is the ratio of the Education completion rate(%) of Least developed countries in 2001 to that in 2010?
Ensure brevity in your answer.  0.78. What is the ratio of the Education completion rate(%) of Iceland in 2001 to that in 2010?
Provide a short and direct response. 0.89. What is the ratio of the Education completion rate(%) of Iran in 2001 to that in 2010?
Provide a short and direct response. 0.86. What is the ratio of the Education completion rate(%) in Macao in 2001 to that in 2010?
Give a very brief answer. 0.81. What is the ratio of the Education completion rate(%) of Least developed countries in 2002 to that in 2003?
Give a very brief answer. 0.98. What is the ratio of the Education completion rate(%) in Iceland in 2002 to that in 2003?
Offer a very short reply. 0.9. What is the ratio of the Education completion rate(%) in Iran in 2002 to that in 2003?
Your response must be concise. 0.89. What is the ratio of the Education completion rate(%) in Macao in 2002 to that in 2003?
Offer a very short reply. 0.93. What is the ratio of the Education completion rate(%) of Least developed countries in 2002 to that in 2006?
Ensure brevity in your answer.  0.9. What is the ratio of the Education completion rate(%) in Iceland in 2002 to that in 2006?
Give a very brief answer. 0.85. What is the ratio of the Education completion rate(%) in Iran in 2002 to that in 2006?
Your answer should be very brief. 0.88. What is the ratio of the Education completion rate(%) in Macao in 2002 to that in 2006?
Your response must be concise. 0.78. What is the ratio of the Education completion rate(%) of Least developed countries in 2002 to that in 2009?
Provide a succinct answer. 0.81. What is the ratio of the Education completion rate(%) of Iceland in 2002 to that in 2009?
Make the answer very short. 0.93. What is the ratio of the Education completion rate(%) in Iran in 2002 to that in 2009?
Keep it short and to the point. 0.82. What is the ratio of the Education completion rate(%) in Macao in 2002 to that in 2009?
Offer a terse response. 0.92. What is the ratio of the Education completion rate(%) of Least developed countries in 2002 to that in 2010?
Your response must be concise. 0.8. What is the ratio of the Education completion rate(%) in Iceland in 2002 to that in 2010?
Provide a succinct answer. 0.94. What is the ratio of the Education completion rate(%) in Iran in 2002 to that in 2010?
Keep it short and to the point. 0.85. What is the ratio of the Education completion rate(%) in Macao in 2002 to that in 2010?
Make the answer very short. 0.86. What is the ratio of the Education completion rate(%) of Least developed countries in 2003 to that in 2006?
Offer a very short reply. 0.92. What is the ratio of the Education completion rate(%) of Iceland in 2003 to that in 2006?
Provide a short and direct response. 0.94. What is the ratio of the Education completion rate(%) in Macao in 2003 to that in 2006?
Ensure brevity in your answer.  0.84. What is the ratio of the Education completion rate(%) in Least developed countries in 2003 to that in 2009?
Provide a succinct answer. 0.83. What is the ratio of the Education completion rate(%) in Iran in 2003 to that in 2009?
Your response must be concise. 0.92. What is the ratio of the Education completion rate(%) in Least developed countries in 2003 to that in 2010?
Provide a short and direct response. 0.82. What is the ratio of the Education completion rate(%) of Iceland in 2003 to that in 2010?
Ensure brevity in your answer.  1.03. What is the ratio of the Education completion rate(%) of Iran in 2003 to that in 2010?
Make the answer very short. 0.95. What is the ratio of the Education completion rate(%) in Macao in 2003 to that in 2010?
Your answer should be very brief. 0.92. What is the ratio of the Education completion rate(%) in Least developed countries in 2006 to that in 2009?
Your answer should be compact. 0.9. What is the ratio of the Education completion rate(%) in Iceland in 2006 to that in 2009?
Offer a very short reply. 1.09. What is the ratio of the Education completion rate(%) of Iran in 2006 to that in 2009?
Provide a short and direct response. 0.93. What is the ratio of the Education completion rate(%) of Macao in 2006 to that in 2009?
Your answer should be compact. 1.18. What is the ratio of the Education completion rate(%) of Least developed countries in 2006 to that in 2010?
Provide a short and direct response. 0.89. What is the ratio of the Education completion rate(%) in Iceland in 2006 to that in 2010?
Keep it short and to the point. 1.1. What is the ratio of the Education completion rate(%) of Iran in 2006 to that in 2010?
Make the answer very short. 0.96. What is the ratio of the Education completion rate(%) in Macao in 2006 to that in 2010?
Your answer should be very brief. 1.1. What is the ratio of the Education completion rate(%) in Least developed countries in 2009 to that in 2010?
Provide a short and direct response. 0.99. What is the ratio of the Education completion rate(%) of Iceland in 2009 to that in 2010?
Your answer should be very brief. 1.01. What is the ratio of the Education completion rate(%) in Iran in 2009 to that in 2010?
Give a very brief answer. 1.04. What is the ratio of the Education completion rate(%) in Macao in 2009 to that in 2010?
Your answer should be compact. 0.93. What is the difference between the highest and the second highest Education completion rate(%) of Least developed countries?
Provide a short and direct response. 0.51. What is the difference between the highest and the second highest Education completion rate(%) in Iceland?
Your answer should be compact. 6.58. What is the difference between the highest and the second highest Education completion rate(%) in Iran?
Your response must be concise. 3.15. What is the difference between the highest and the second highest Education completion rate(%) of Macao?
Your response must be concise. 8.63. What is the difference between the highest and the lowest Education completion rate(%) of Least developed countries?
Ensure brevity in your answer.  9.96. What is the difference between the highest and the lowest Education completion rate(%) of Iceland?
Your response must be concise. 20.23. What is the difference between the highest and the lowest Education completion rate(%) of Iran?
Offer a very short reply. 16.96. What is the difference between the highest and the lowest Education completion rate(%) of Macao?
Your answer should be very brief. 29.37. 